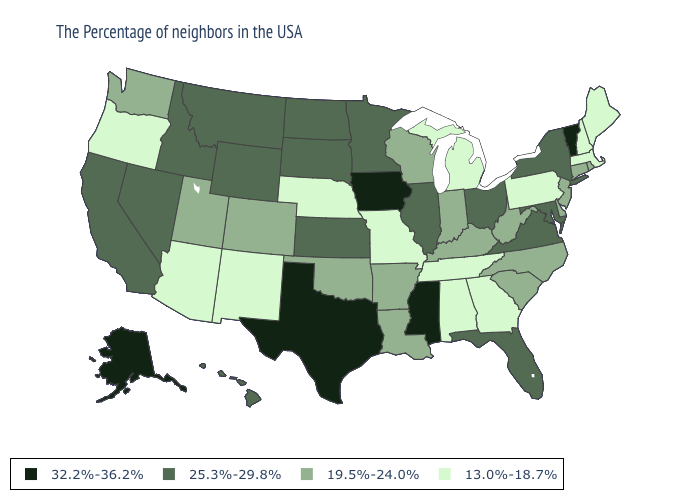Among the states that border South Carolina , which have the lowest value?
Answer briefly. Georgia. What is the value of New Mexico?
Keep it brief. 13.0%-18.7%. Name the states that have a value in the range 19.5%-24.0%?
Give a very brief answer. Rhode Island, Connecticut, New Jersey, Delaware, North Carolina, South Carolina, West Virginia, Kentucky, Indiana, Wisconsin, Louisiana, Arkansas, Oklahoma, Colorado, Utah, Washington. Name the states that have a value in the range 25.3%-29.8%?
Be succinct. New York, Maryland, Virginia, Ohio, Florida, Illinois, Minnesota, Kansas, South Dakota, North Dakota, Wyoming, Montana, Idaho, Nevada, California, Hawaii. What is the highest value in the South ?
Keep it brief. 32.2%-36.2%. Which states have the lowest value in the MidWest?
Concise answer only. Michigan, Missouri, Nebraska. Does Delaware have a higher value than Texas?
Give a very brief answer. No. What is the value of Vermont?
Quick response, please. 32.2%-36.2%. Name the states that have a value in the range 19.5%-24.0%?
Short answer required. Rhode Island, Connecticut, New Jersey, Delaware, North Carolina, South Carolina, West Virginia, Kentucky, Indiana, Wisconsin, Louisiana, Arkansas, Oklahoma, Colorado, Utah, Washington. Does the map have missing data?
Give a very brief answer. No. Is the legend a continuous bar?
Be succinct. No. Name the states that have a value in the range 32.2%-36.2%?
Quick response, please. Vermont, Mississippi, Iowa, Texas, Alaska. What is the value of Nevada?
Keep it brief. 25.3%-29.8%. Name the states that have a value in the range 19.5%-24.0%?
Concise answer only. Rhode Island, Connecticut, New Jersey, Delaware, North Carolina, South Carolina, West Virginia, Kentucky, Indiana, Wisconsin, Louisiana, Arkansas, Oklahoma, Colorado, Utah, Washington. Name the states that have a value in the range 19.5%-24.0%?
Short answer required. Rhode Island, Connecticut, New Jersey, Delaware, North Carolina, South Carolina, West Virginia, Kentucky, Indiana, Wisconsin, Louisiana, Arkansas, Oklahoma, Colorado, Utah, Washington. 